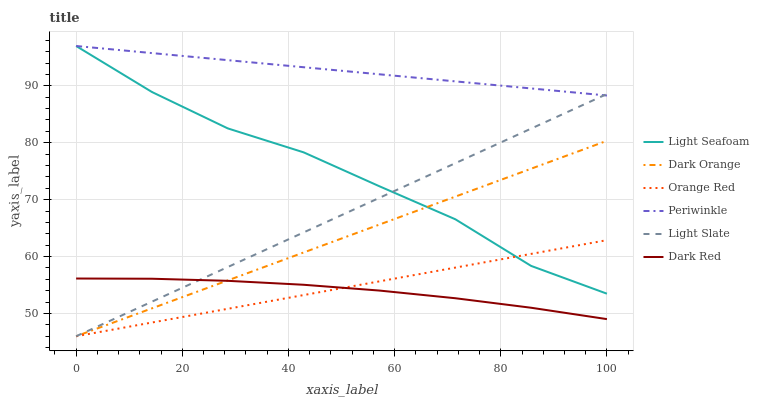Does Dark Red have the minimum area under the curve?
Answer yes or no. Yes. Does Periwinkle have the maximum area under the curve?
Answer yes or no. Yes. Does Light Slate have the minimum area under the curve?
Answer yes or no. No. Does Light Slate have the maximum area under the curve?
Answer yes or no. No. Is Orange Red the smoothest?
Answer yes or no. Yes. Is Light Seafoam the roughest?
Answer yes or no. Yes. Is Light Slate the smoothest?
Answer yes or no. No. Is Light Slate the roughest?
Answer yes or no. No. Does Dark Orange have the lowest value?
Answer yes or no. Yes. Does Dark Red have the lowest value?
Answer yes or no. No. Does Light Seafoam have the highest value?
Answer yes or no. Yes. Does Light Slate have the highest value?
Answer yes or no. No. Is Orange Red less than Periwinkle?
Answer yes or no. Yes. Is Periwinkle greater than Orange Red?
Answer yes or no. Yes. Does Orange Red intersect Light Seafoam?
Answer yes or no. Yes. Is Orange Red less than Light Seafoam?
Answer yes or no. No. Is Orange Red greater than Light Seafoam?
Answer yes or no. No. Does Orange Red intersect Periwinkle?
Answer yes or no. No. 